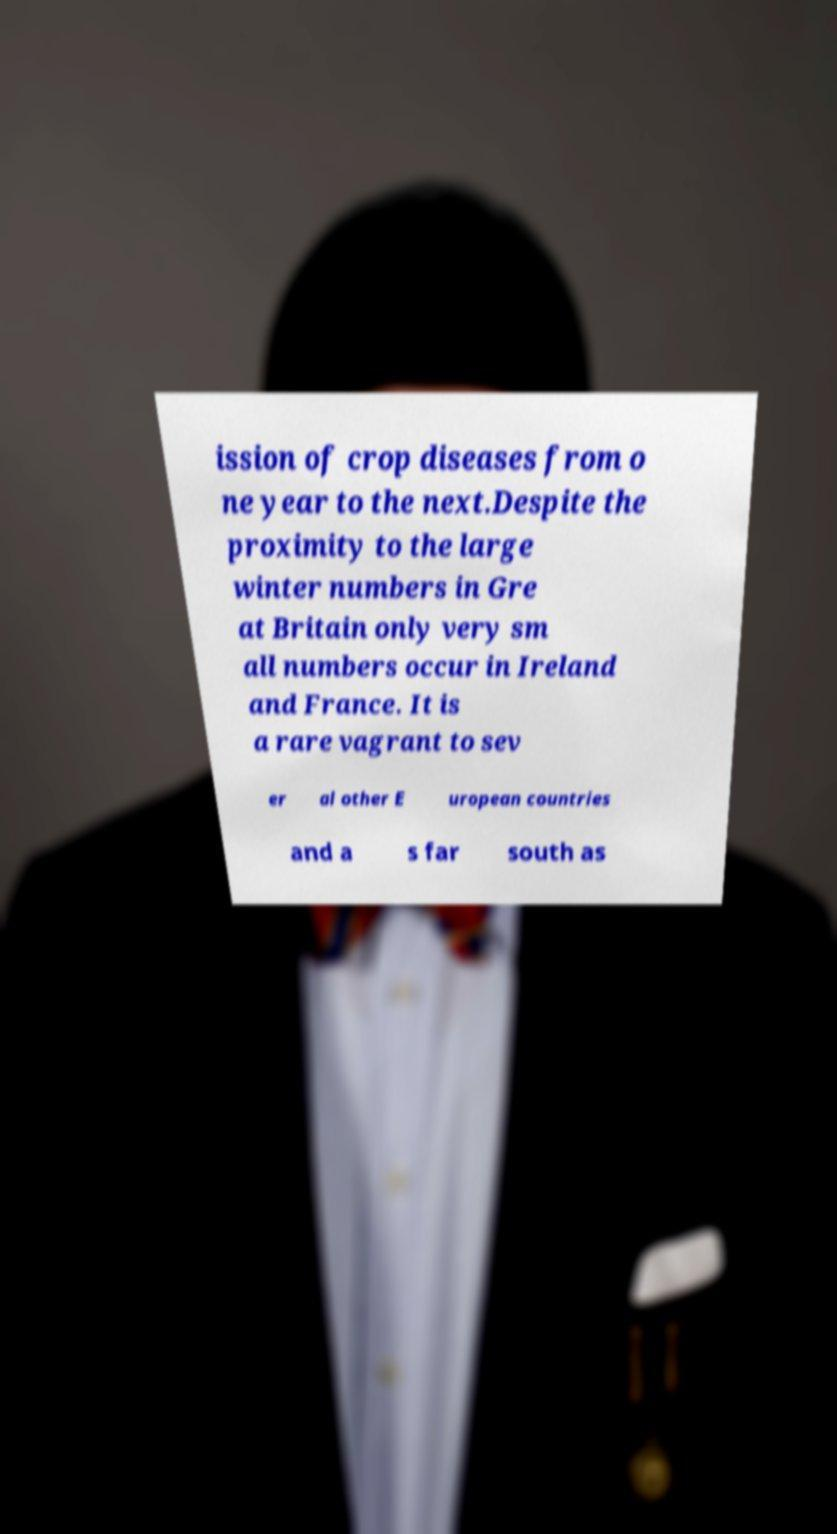What messages or text are displayed in this image? I need them in a readable, typed format. ission of crop diseases from o ne year to the next.Despite the proximity to the large winter numbers in Gre at Britain only very sm all numbers occur in Ireland and France. It is a rare vagrant to sev er al other E uropean countries and a s far south as 